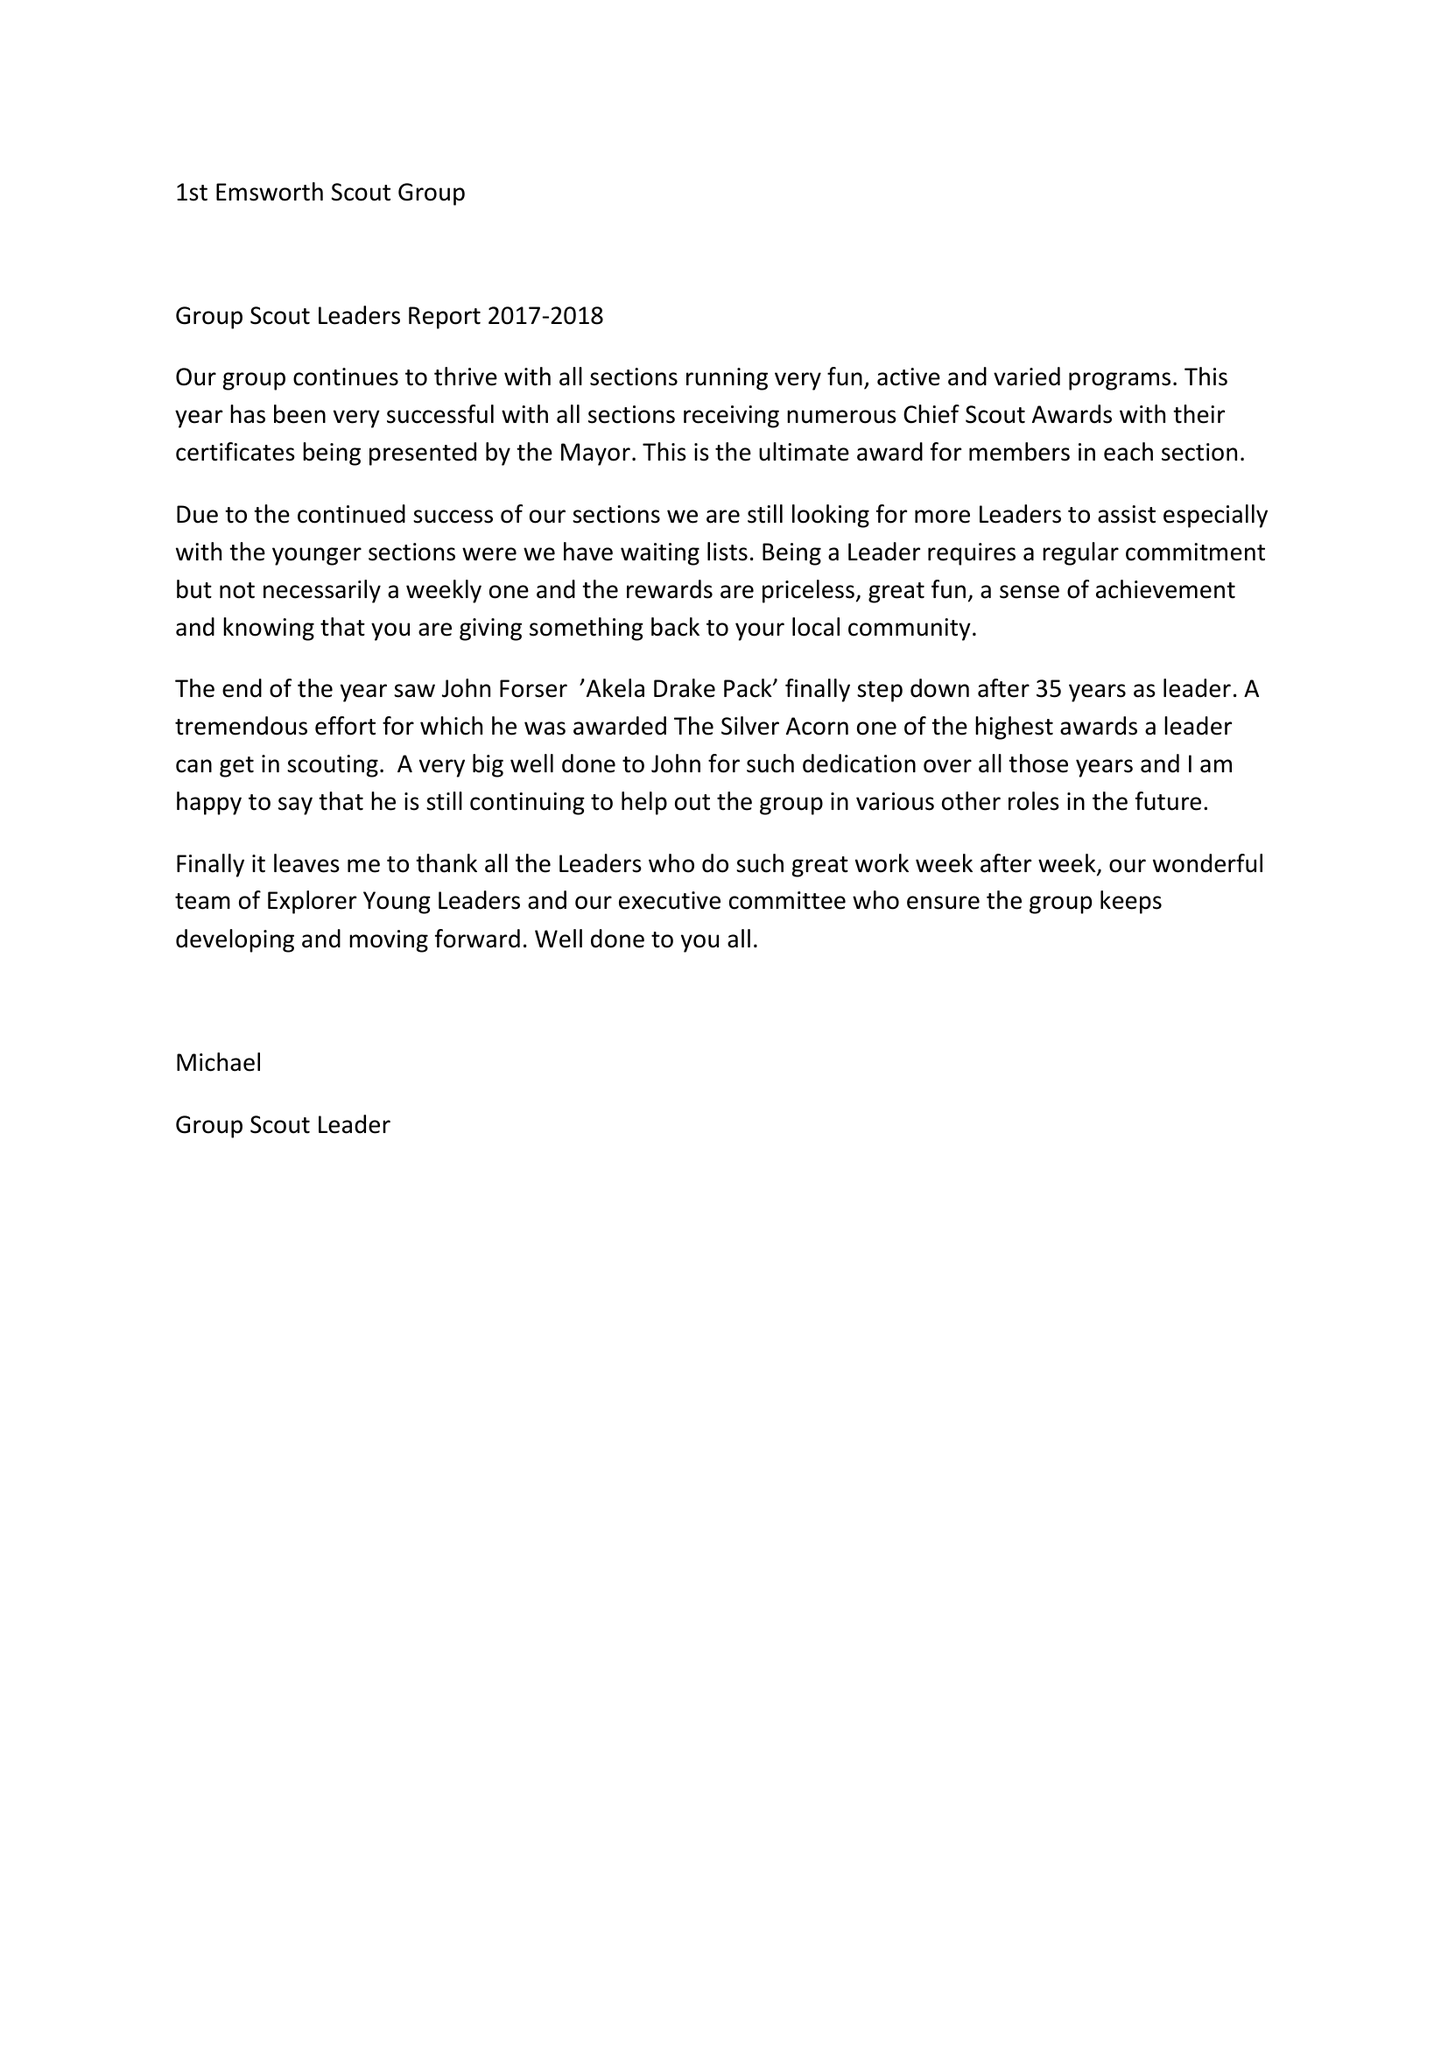What is the value for the charity_number?
Answer the question using a single word or phrase. 302246 